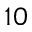Convert formula to latex. <formula><loc_0><loc_0><loc_500><loc_500>1 0</formula> 